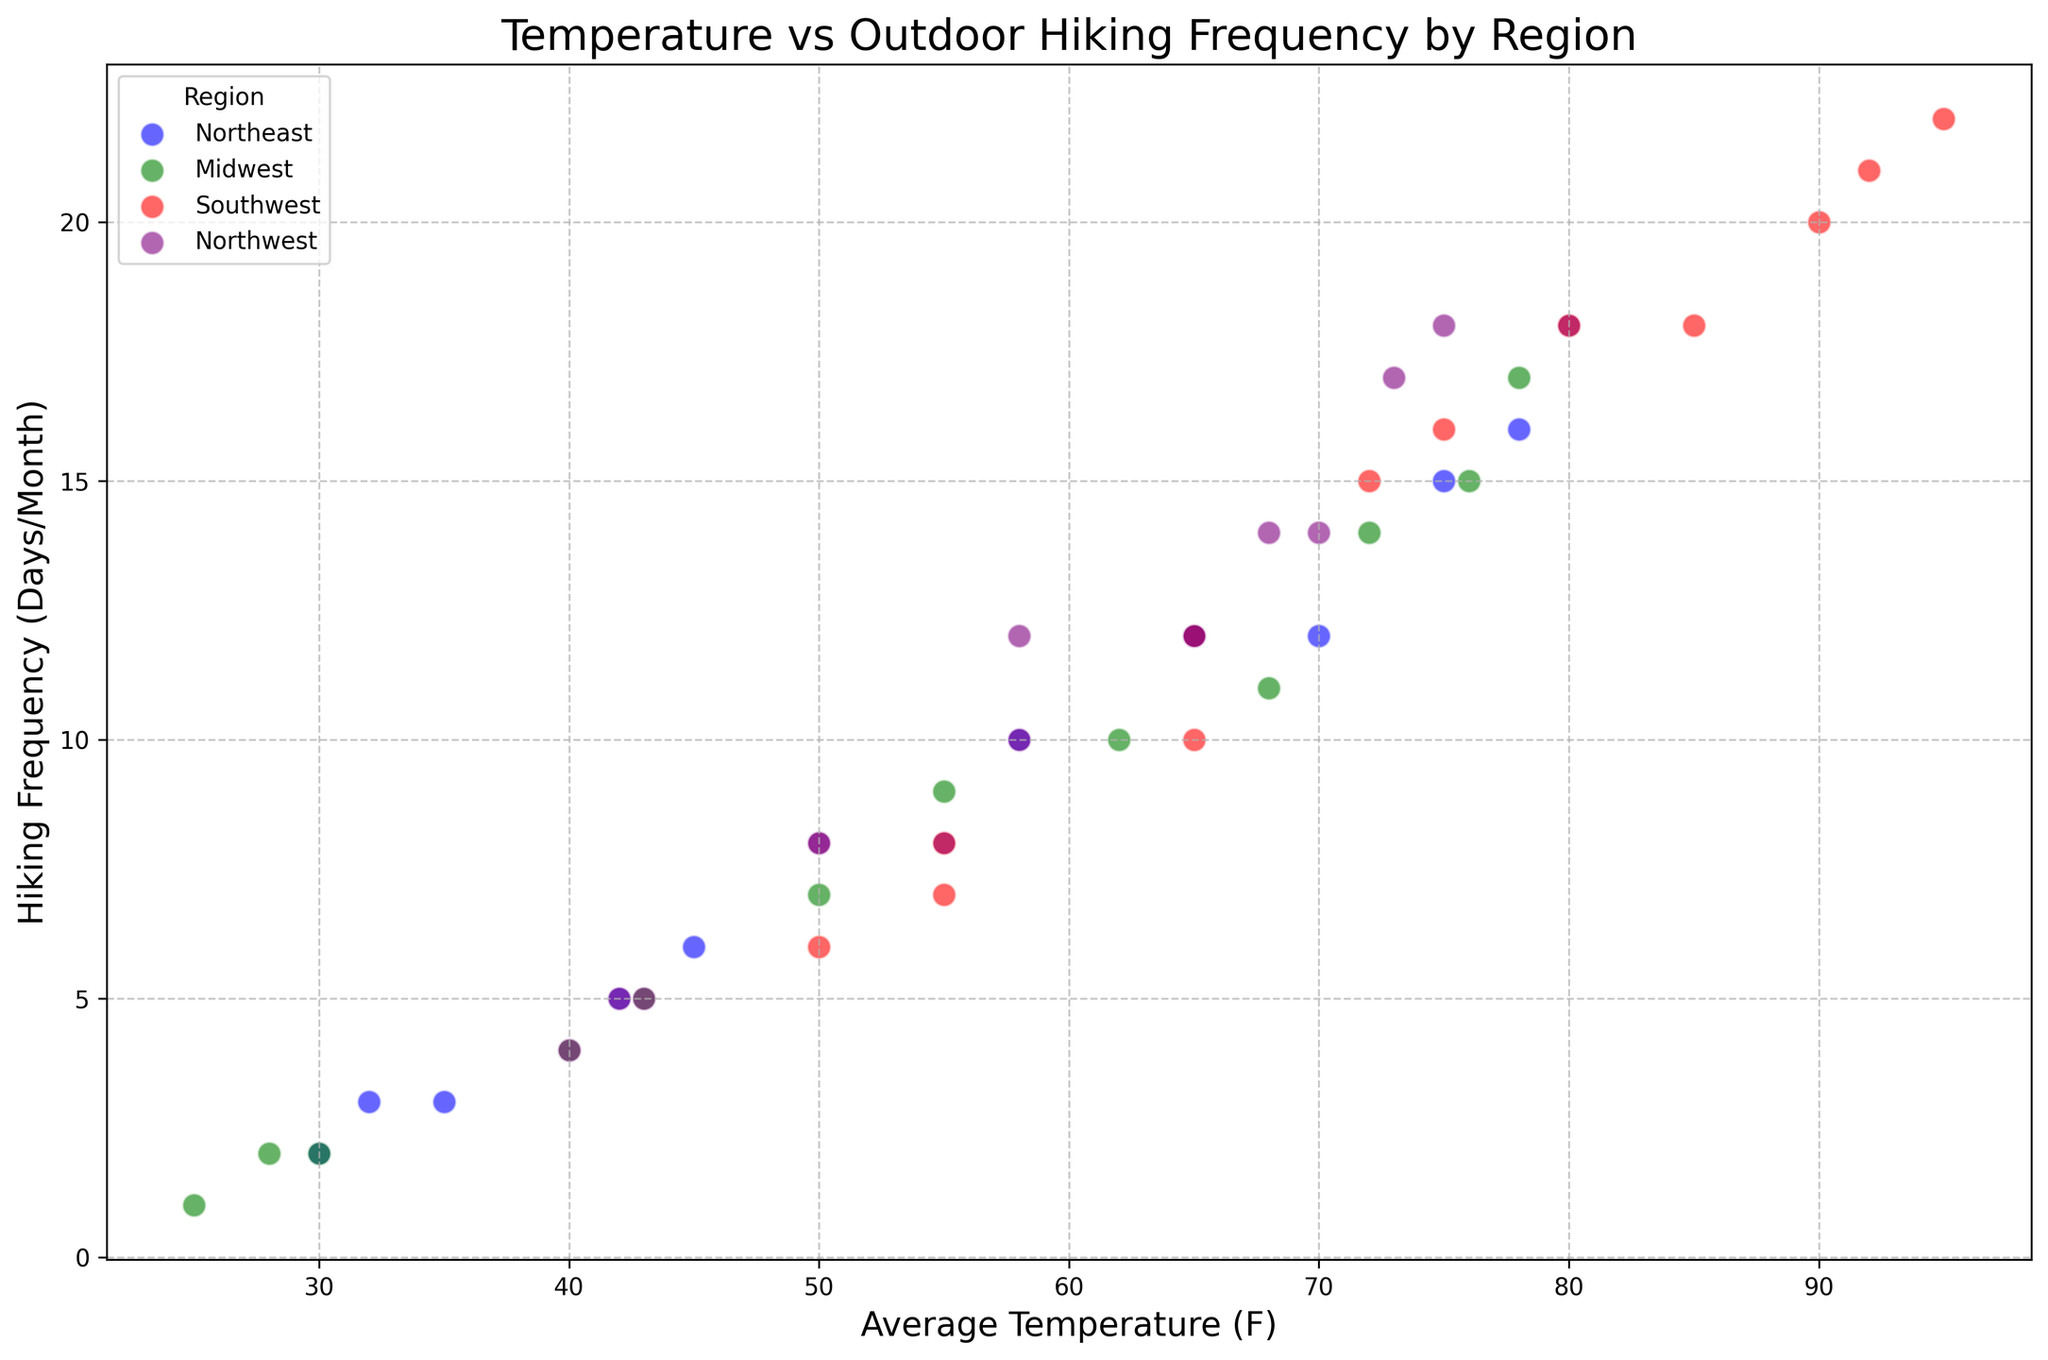Which region has the highest hiking frequency at the highest average temperature? The highest average temperature in the data is 95°F, which occurs in the Southwest region in July. Checking the hiking frequency for this temperature, it's 22 days/month.
Answer: Southwest In which month does the Northeast region have the greatest increase in hiking frequency compared to the previous month? Comparing hiking frequencies month to month in the Northeast: Feb-Jan (3-2=1), Mar-Feb (5-3=2), Apr-Mar (8-5=3), May-Apr (12-8=4), Jun-May (15-12=3), Jul-Jun (18-15=3), Aug-Jul (16-18=-2), Sep-Aug (12-16=-4), Oct-Sep (10-12=-2), Nov-Oct (6-10=-4), Dec-Nov (3-6=-3). The greatest increase is from April to May, a difference of 4 days/month.
Answer: May Which region has the most consistent relationship between temperature and hiking frequency? By observing the scatter plot, regions where data points show a linear relationship indicate consistency. Comparing the regions, the Southwest shows a clear upward trend (as temperature increases, hiking frequency also increases), suggesting it has the most consistent relationship.
Answer: Southwest How does the hiking frequency in the Northwest region at 58°F compare to the Midwest region at the same temperature? From the plot, the Northwest has a hiking frequency of 10 days/month at 58°F, while the Midwest has a hiking frequency of 9 days/month at the same temperature.
Answer: Northwest is higher Across all regions, what temperature range shows the highest variance in hiking frequencies? Examining the vertical spread of points along the temperature axis: the temperatures around 58°F and 62°F have the widest range of hiking frequencies, varying from as low as 7 days/month to as high as 12 days/month and 10 to 18 days/month, respectively.
Answer: 58°F - 62°F Is there a month where all regions have a uniform hiking frequency? By visually checking each month in the scatter plot, no single month displays data points clustered together across all regions. Each month shows some variation in hiking frequency.
Answer: No What is the temperature in the Midwest when the hiking frequency is equal to that of the Northeast at 6 days/month? For the Northeast, the hiking frequency is 6 days/month in November (45°F). In the Midwest, the plot shows a data point at 6 days/month for November as well, which also corresponds to 43°F.
Answer: 43°F Which region displays an outlier point in terms of hiking frequency that does not follow the trend seen in other regions? Observing for outliers that deviate from the trend, the Southwest in July shows an exceptionally high frequency (22 days) even though the temperature is quite high (95°F), which might not follow the expectable trend observed in other regions.
Answer: Southwest Do any regions have a hiking frequency of 15 days/month for different temperatures? Checking the scatter plot, the Southwest has a hiking frequency of 15 days/month at 72°F (April) and the Midwest also has it in June for 72°F.
Answer: Yes Are there regions where higher temperatures correspond to a decrease in hiking frequency? Observing the trend for each region, it is seen that for the Northeast from July (80°F, 18 days) to August (78°F, 16 days) and for the Midwest from July (78°F, 17 days) to August (76°F, 15 days), a slight decrease is present, indicating a decrease in hiking frequency with a higher temperature.
Answer: Yes 